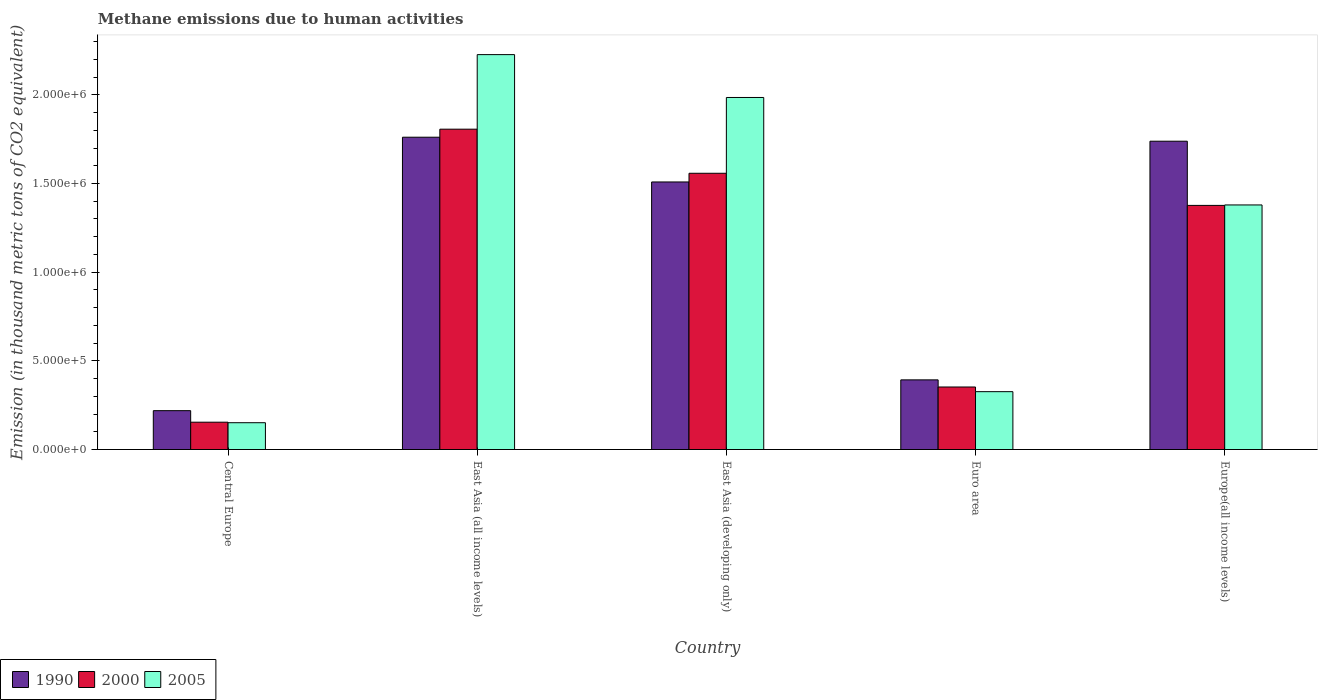How many different coloured bars are there?
Your answer should be very brief. 3. Are the number of bars per tick equal to the number of legend labels?
Ensure brevity in your answer.  Yes. What is the label of the 2nd group of bars from the left?
Your answer should be very brief. East Asia (all income levels). What is the amount of methane emitted in 2000 in East Asia (all income levels)?
Provide a succinct answer. 1.81e+06. Across all countries, what is the maximum amount of methane emitted in 2000?
Make the answer very short. 1.81e+06. Across all countries, what is the minimum amount of methane emitted in 2005?
Provide a short and direct response. 1.51e+05. In which country was the amount of methane emitted in 1990 maximum?
Offer a very short reply. East Asia (all income levels). In which country was the amount of methane emitted in 2005 minimum?
Give a very brief answer. Central Europe. What is the total amount of methane emitted in 1990 in the graph?
Ensure brevity in your answer.  5.62e+06. What is the difference between the amount of methane emitted in 1990 in East Asia (all income levels) and that in Euro area?
Your answer should be compact. 1.37e+06. What is the difference between the amount of methane emitted in 1990 in East Asia (all income levels) and the amount of methane emitted in 2000 in Europe(all income levels)?
Your answer should be very brief. 3.85e+05. What is the average amount of methane emitted in 2005 per country?
Give a very brief answer. 1.21e+06. What is the difference between the amount of methane emitted of/in 1990 and amount of methane emitted of/in 2000 in East Asia (developing only)?
Ensure brevity in your answer.  -4.90e+04. What is the ratio of the amount of methane emitted in 1990 in Central Europe to that in Europe(all income levels)?
Offer a very short reply. 0.13. Is the difference between the amount of methane emitted in 1990 in East Asia (all income levels) and Europe(all income levels) greater than the difference between the amount of methane emitted in 2000 in East Asia (all income levels) and Europe(all income levels)?
Your answer should be very brief. No. What is the difference between the highest and the second highest amount of methane emitted in 2000?
Your response must be concise. 2.49e+05. What is the difference between the highest and the lowest amount of methane emitted in 2005?
Offer a very short reply. 2.08e+06. In how many countries, is the amount of methane emitted in 2005 greater than the average amount of methane emitted in 2005 taken over all countries?
Provide a succinct answer. 3. Is the sum of the amount of methane emitted in 2005 in Central Europe and Europe(all income levels) greater than the maximum amount of methane emitted in 1990 across all countries?
Provide a succinct answer. No. What does the 1st bar from the right in Europe(all income levels) represents?
Your response must be concise. 2005. Where does the legend appear in the graph?
Give a very brief answer. Bottom left. How are the legend labels stacked?
Keep it short and to the point. Horizontal. What is the title of the graph?
Your response must be concise. Methane emissions due to human activities. Does "1963" appear as one of the legend labels in the graph?
Offer a terse response. No. What is the label or title of the X-axis?
Your answer should be very brief. Country. What is the label or title of the Y-axis?
Your answer should be compact. Emission (in thousand metric tons of CO2 equivalent). What is the Emission (in thousand metric tons of CO2 equivalent) of 1990 in Central Europe?
Make the answer very short. 2.19e+05. What is the Emission (in thousand metric tons of CO2 equivalent) in 2000 in Central Europe?
Ensure brevity in your answer.  1.54e+05. What is the Emission (in thousand metric tons of CO2 equivalent) in 2005 in Central Europe?
Keep it short and to the point. 1.51e+05. What is the Emission (in thousand metric tons of CO2 equivalent) of 1990 in East Asia (all income levels)?
Your answer should be very brief. 1.76e+06. What is the Emission (in thousand metric tons of CO2 equivalent) of 2000 in East Asia (all income levels)?
Make the answer very short. 1.81e+06. What is the Emission (in thousand metric tons of CO2 equivalent) in 2005 in East Asia (all income levels)?
Make the answer very short. 2.23e+06. What is the Emission (in thousand metric tons of CO2 equivalent) of 1990 in East Asia (developing only)?
Ensure brevity in your answer.  1.51e+06. What is the Emission (in thousand metric tons of CO2 equivalent) in 2000 in East Asia (developing only)?
Make the answer very short. 1.56e+06. What is the Emission (in thousand metric tons of CO2 equivalent) in 2005 in East Asia (developing only)?
Offer a terse response. 1.99e+06. What is the Emission (in thousand metric tons of CO2 equivalent) of 1990 in Euro area?
Offer a very short reply. 3.93e+05. What is the Emission (in thousand metric tons of CO2 equivalent) in 2000 in Euro area?
Offer a terse response. 3.53e+05. What is the Emission (in thousand metric tons of CO2 equivalent) of 2005 in Euro area?
Offer a very short reply. 3.26e+05. What is the Emission (in thousand metric tons of CO2 equivalent) of 1990 in Europe(all income levels)?
Your response must be concise. 1.74e+06. What is the Emission (in thousand metric tons of CO2 equivalent) in 2000 in Europe(all income levels)?
Keep it short and to the point. 1.38e+06. What is the Emission (in thousand metric tons of CO2 equivalent) of 2005 in Europe(all income levels)?
Make the answer very short. 1.38e+06. Across all countries, what is the maximum Emission (in thousand metric tons of CO2 equivalent) of 1990?
Give a very brief answer. 1.76e+06. Across all countries, what is the maximum Emission (in thousand metric tons of CO2 equivalent) of 2000?
Offer a very short reply. 1.81e+06. Across all countries, what is the maximum Emission (in thousand metric tons of CO2 equivalent) in 2005?
Keep it short and to the point. 2.23e+06. Across all countries, what is the minimum Emission (in thousand metric tons of CO2 equivalent) in 1990?
Your answer should be compact. 2.19e+05. Across all countries, what is the minimum Emission (in thousand metric tons of CO2 equivalent) in 2000?
Give a very brief answer. 1.54e+05. Across all countries, what is the minimum Emission (in thousand metric tons of CO2 equivalent) in 2005?
Give a very brief answer. 1.51e+05. What is the total Emission (in thousand metric tons of CO2 equivalent) of 1990 in the graph?
Give a very brief answer. 5.62e+06. What is the total Emission (in thousand metric tons of CO2 equivalent) in 2000 in the graph?
Make the answer very short. 5.25e+06. What is the total Emission (in thousand metric tons of CO2 equivalent) in 2005 in the graph?
Your answer should be compact. 6.07e+06. What is the difference between the Emission (in thousand metric tons of CO2 equivalent) in 1990 in Central Europe and that in East Asia (all income levels)?
Your answer should be compact. -1.54e+06. What is the difference between the Emission (in thousand metric tons of CO2 equivalent) of 2000 in Central Europe and that in East Asia (all income levels)?
Your answer should be compact. -1.65e+06. What is the difference between the Emission (in thousand metric tons of CO2 equivalent) in 2005 in Central Europe and that in East Asia (all income levels)?
Offer a terse response. -2.08e+06. What is the difference between the Emission (in thousand metric tons of CO2 equivalent) of 1990 in Central Europe and that in East Asia (developing only)?
Give a very brief answer. -1.29e+06. What is the difference between the Emission (in thousand metric tons of CO2 equivalent) in 2000 in Central Europe and that in East Asia (developing only)?
Ensure brevity in your answer.  -1.40e+06. What is the difference between the Emission (in thousand metric tons of CO2 equivalent) of 2005 in Central Europe and that in East Asia (developing only)?
Your response must be concise. -1.83e+06. What is the difference between the Emission (in thousand metric tons of CO2 equivalent) of 1990 in Central Europe and that in Euro area?
Keep it short and to the point. -1.74e+05. What is the difference between the Emission (in thousand metric tons of CO2 equivalent) of 2000 in Central Europe and that in Euro area?
Make the answer very short. -1.98e+05. What is the difference between the Emission (in thousand metric tons of CO2 equivalent) of 2005 in Central Europe and that in Euro area?
Make the answer very short. -1.75e+05. What is the difference between the Emission (in thousand metric tons of CO2 equivalent) of 1990 in Central Europe and that in Europe(all income levels)?
Provide a succinct answer. -1.52e+06. What is the difference between the Emission (in thousand metric tons of CO2 equivalent) of 2000 in Central Europe and that in Europe(all income levels)?
Offer a terse response. -1.22e+06. What is the difference between the Emission (in thousand metric tons of CO2 equivalent) of 2005 in Central Europe and that in Europe(all income levels)?
Your response must be concise. -1.23e+06. What is the difference between the Emission (in thousand metric tons of CO2 equivalent) of 1990 in East Asia (all income levels) and that in East Asia (developing only)?
Offer a terse response. 2.52e+05. What is the difference between the Emission (in thousand metric tons of CO2 equivalent) of 2000 in East Asia (all income levels) and that in East Asia (developing only)?
Offer a terse response. 2.49e+05. What is the difference between the Emission (in thousand metric tons of CO2 equivalent) in 2005 in East Asia (all income levels) and that in East Asia (developing only)?
Your response must be concise. 2.42e+05. What is the difference between the Emission (in thousand metric tons of CO2 equivalent) of 1990 in East Asia (all income levels) and that in Euro area?
Make the answer very short. 1.37e+06. What is the difference between the Emission (in thousand metric tons of CO2 equivalent) of 2000 in East Asia (all income levels) and that in Euro area?
Offer a very short reply. 1.45e+06. What is the difference between the Emission (in thousand metric tons of CO2 equivalent) in 2005 in East Asia (all income levels) and that in Euro area?
Offer a terse response. 1.90e+06. What is the difference between the Emission (in thousand metric tons of CO2 equivalent) in 1990 in East Asia (all income levels) and that in Europe(all income levels)?
Provide a short and direct response. 2.26e+04. What is the difference between the Emission (in thousand metric tons of CO2 equivalent) in 2000 in East Asia (all income levels) and that in Europe(all income levels)?
Offer a very short reply. 4.30e+05. What is the difference between the Emission (in thousand metric tons of CO2 equivalent) of 2005 in East Asia (all income levels) and that in Europe(all income levels)?
Provide a short and direct response. 8.48e+05. What is the difference between the Emission (in thousand metric tons of CO2 equivalent) of 1990 in East Asia (developing only) and that in Euro area?
Your answer should be compact. 1.12e+06. What is the difference between the Emission (in thousand metric tons of CO2 equivalent) in 2000 in East Asia (developing only) and that in Euro area?
Your answer should be very brief. 1.21e+06. What is the difference between the Emission (in thousand metric tons of CO2 equivalent) in 2005 in East Asia (developing only) and that in Euro area?
Your answer should be compact. 1.66e+06. What is the difference between the Emission (in thousand metric tons of CO2 equivalent) of 1990 in East Asia (developing only) and that in Europe(all income levels)?
Offer a terse response. -2.30e+05. What is the difference between the Emission (in thousand metric tons of CO2 equivalent) of 2000 in East Asia (developing only) and that in Europe(all income levels)?
Your response must be concise. 1.81e+05. What is the difference between the Emission (in thousand metric tons of CO2 equivalent) in 2005 in East Asia (developing only) and that in Europe(all income levels)?
Your response must be concise. 6.06e+05. What is the difference between the Emission (in thousand metric tons of CO2 equivalent) of 1990 in Euro area and that in Europe(all income levels)?
Your response must be concise. -1.35e+06. What is the difference between the Emission (in thousand metric tons of CO2 equivalent) in 2000 in Euro area and that in Europe(all income levels)?
Provide a short and direct response. -1.02e+06. What is the difference between the Emission (in thousand metric tons of CO2 equivalent) of 2005 in Euro area and that in Europe(all income levels)?
Make the answer very short. -1.05e+06. What is the difference between the Emission (in thousand metric tons of CO2 equivalent) of 1990 in Central Europe and the Emission (in thousand metric tons of CO2 equivalent) of 2000 in East Asia (all income levels)?
Keep it short and to the point. -1.59e+06. What is the difference between the Emission (in thousand metric tons of CO2 equivalent) in 1990 in Central Europe and the Emission (in thousand metric tons of CO2 equivalent) in 2005 in East Asia (all income levels)?
Provide a short and direct response. -2.01e+06. What is the difference between the Emission (in thousand metric tons of CO2 equivalent) in 2000 in Central Europe and the Emission (in thousand metric tons of CO2 equivalent) in 2005 in East Asia (all income levels)?
Keep it short and to the point. -2.07e+06. What is the difference between the Emission (in thousand metric tons of CO2 equivalent) of 1990 in Central Europe and the Emission (in thousand metric tons of CO2 equivalent) of 2000 in East Asia (developing only)?
Your answer should be very brief. -1.34e+06. What is the difference between the Emission (in thousand metric tons of CO2 equivalent) of 1990 in Central Europe and the Emission (in thousand metric tons of CO2 equivalent) of 2005 in East Asia (developing only)?
Keep it short and to the point. -1.77e+06. What is the difference between the Emission (in thousand metric tons of CO2 equivalent) in 2000 in Central Europe and the Emission (in thousand metric tons of CO2 equivalent) in 2005 in East Asia (developing only)?
Provide a short and direct response. -1.83e+06. What is the difference between the Emission (in thousand metric tons of CO2 equivalent) of 1990 in Central Europe and the Emission (in thousand metric tons of CO2 equivalent) of 2000 in Euro area?
Provide a succinct answer. -1.33e+05. What is the difference between the Emission (in thousand metric tons of CO2 equivalent) in 1990 in Central Europe and the Emission (in thousand metric tons of CO2 equivalent) in 2005 in Euro area?
Your response must be concise. -1.07e+05. What is the difference between the Emission (in thousand metric tons of CO2 equivalent) in 2000 in Central Europe and the Emission (in thousand metric tons of CO2 equivalent) in 2005 in Euro area?
Keep it short and to the point. -1.72e+05. What is the difference between the Emission (in thousand metric tons of CO2 equivalent) in 1990 in Central Europe and the Emission (in thousand metric tons of CO2 equivalent) in 2000 in Europe(all income levels)?
Make the answer very short. -1.16e+06. What is the difference between the Emission (in thousand metric tons of CO2 equivalent) in 1990 in Central Europe and the Emission (in thousand metric tons of CO2 equivalent) in 2005 in Europe(all income levels)?
Offer a very short reply. -1.16e+06. What is the difference between the Emission (in thousand metric tons of CO2 equivalent) in 2000 in Central Europe and the Emission (in thousand metric tons of CO2 equivalent) in 2005 in Europe(all income levels)?
Make the answer very short. -1.23e+06. What is the difference between the Emission (in thousand metric tons of CO2 equivalent) in 1990 in East Asia (all income levels) and the Emission (in thousand metric tons of CO2 equivalent) in 2000 in East Asia (developing only)?
Offer a very short reply. 2.03e+05. What is the difference between the Emission (in thousand metric tons of CO2 equivalent) in 1990 in East Asia (all income levels) and the Emission (in thousand metric tons of CO2 equivalent) in 2005 in East Asia (developing only)?
Your response must be concise. -2.24e+05. What is the difference between the Emission (in thousand metric tons of CO2 equivalent) of 2000 in East Asia (all income levels) and the Emission (in thousand metric tons of CO2 equivalent) of 2005 in East Asia (developing only)?
Offer a terse response. -1.79e+05. What is the difference between the Emission (in thousand metric tons of CO2 equivalent) of 1990 in East Asia (all income levels) and the Emission (in thousand metric tons of CO2 equivalent) of 2000 in Euro area?
Your response must be concise. 1.41e+06. What is the difference between the Emission (in thousand metric tons of CO2 equivalent) in 1990 in East Asia (all income levels) and the Emission (in thousand metric tons of CO2 equivalent) in 2005 in Euro area?
Keep it short and to the point. 1.43e+06. What is the difference between the Emission (in thousand metric tons of CO2 equivalent) in 2000 in East Asia (all income levels) and the Emission (in thousand metric tons of CO2 equivalent) in 2005 in Euro area?
Keep it short and to the point. 1.48e+06. What is the difference between the Emission (in thousand metric tons of CO2 equivalent) in 1990 in East Asia (all income levels) and the Emission (in thousand metric tons of CO2 equivalent) in 2000 in Europe(all income levels)?
Your response must be concise. 3.85e+05. What is the difference between the Emission (in thousand metric tons of CO2 equivalent) of 1990 in East Asia (all income levels) and the Emission (in thousand metric tons of CO2 equivalent) of 2005 in Europe(all income levels)?
Keep it short and to the point. 3.82e+05. What is the difference between the Emission (in thousand metric tons of CO2 equivalent) in 2000 in East Asia (all income levels) and the Emission (in thousand metric tons of CO2 equivalent) in 2005 in Europe(all income levels)?
Make the answer very short. 4.27e+05. What is the difference between the Emission (in thousand metric tons of CO2 equivalent) of 1990 in East Asia (developing only) and the Emission (in thousand metric tons of CO2 equivalent) of 2000 in Euro area?
Offer a very short reply. 1.16e+06. What is the difference between the Emission (in thousand metric tons of CO2 equivalent) in 1990 in East Asia (developing only) and the Emission (in thousand metric tons of CO2 equivalent) in 2005 in Euro area?
Your answer should be very brief. 1.18e+06. What is the difference between the Emission (in thousand metric tons of CO2 equivalent) of 2000 in East Asia (developing only) and the Emission (in thousand metric tons of CO2 equivalent) of 2005 in Euro area?
Provide a succinct answer. 1.23e+06. What is the difference between the Emission (in thousand metric tons of CO2 equivalent) in 1990 in East Asia (developing only) and the Emission (in thousand metric tons of CO2 equivalent) in 2000 in Europe(all income levels)?
Your answer should be compact. 1.32e+05. What is the difference between the Emission (in thousand metric tons of CO2 equivalent) in 1990 in East Asia (developing only) and the Emission (in thousand metric tons of CO2 equivalent) in 2005 in Europe(all income levels)?
Offer a terse response. 1.30e+05. What is the difference between the Emission (in thousand metric tons of CO2 equivalent) of 2000 in East Asia (developing only) and the Emission (in thousand metric tons of CO2 equivalent) of 2005 in Europe(all income levels)?
Provide a succinct answer. 1.79e+05. What is the difference between the Emission (in thousand metric tons of CO2 equivalent) of 1990 in Euro area and the Emission (in thousand metric tons of CO2 equivalent) of 2000 in Europe(all income levels)?
Ensure brevity in your answer.  -9.84e+05. What is the difference between the Emission (in thousand metric tons of CO2 equivalent) in 1990 in Euro area and the Emission (in thousand metric tons of CO2 equivalent) in 2005 in Europe(all income levels)?
Make the answer very short. -9.86e+05. What is the difference between the Emission (in thousand metric tons of CO2 equivalent) in 2000 in Euro area and the Emission (in thousand metric tons of CO2 equivalent) in 2005 in Europe(all income levels)?
Make the answer very short. -1.03e+06. What is the average Emission (in thousand metric tons of CO2 equivalent) in 1990 per country?
Provide a succinct answer. 1.12e+06. What is the average Emission (in thousand metric tons of CO2 equivalent) of 2000 per country?
Keep it short and to the point. 1.05e+06. What is the average Emission (in thousand metric tons of CO2 equivalent) in 2005 per country?
Your answer should be very brief. 1.21e+06. What is the difference between the Emission (in thousand metric tons of CO2 equivalent) of 1990 and Emission (in thousand metric tons of CO2 equivalent) of 2000 in Central Europe?
Provide a short and direct response. 6.50e+04. What is the difference between the Emission (in thousand metric tons of CO2 equivalent) of 1990 and Emission (in thousand metric tons of CO2 equivalent) of 2005 in Central Europe?
Your answer should be very brief. 6.80e+04. What is the difference between the Emission (in thousand metric tons of CO2 equivalent) in 2000 and Emission (in thousand metric tons of CO2 equivalent) in 2005 in Central Europe?
Your answer should be compact. 2935.3. What is the difference between the Emission (in thousand metric tons of CO2 equivalent) of 1990 and Emission (in thousand metric tons of CO2 equivalent) of 2000 in East Asia (all income levels)?
Offer a terse response. -4.52e+04. What is the difference between the Emission (in thousand metric tons of CO2 equivalent) in 1990 and Emission (in thousand metric tons of CO2 equivalent) in 2005 in East Asia (all income levels)?
Offer a terse response. -4.66e+05. What is the difference between the Emission (in thousand metric tons of CO2 equivalent) in 2000 and Emission (in thousand metric tons of CO2 equivalent) in 2005 in East Asia (all income levels)?
Give a very brief answer. -4.20e+05. What is the difference between the Emission (in thousand metric tons of CO2 equivalent) in 1990 and Emission (in thousand metric tons of CO2 equivalent) in 2000 in East Asia (developing only)?
Offer a very short reply. -4.90e+04. What is the difference between the Emission (in thousand metric tons of CO2 equivalent) in 1990 and Emission (in thousand metric tons of CO2 equivalent) in 2005 in East Asia (developing only)?
Your answer should be compact. -4.76e+05. What is the difference between the Emission (in thousand metric tons of CO2 equivalent) in 2000 and Emission (in thousand metric tons of CO2 equivalent) in 2005 in East Asia (developing only)?
Your answer should be compact. -4.27e+05. What is the difference between the Emission (in thousand metric tons of CO2 equivalent) of 1990 and Emission (in thousand metric tons of CO2 equivalent) of 2000 in Euro area?
Offer a very short reply. 4.02e+04. What is the difference between the Emission (in thousand metric tons of CO2 equivalent) of 1990 and Emission (in thousand metric tons of CO2 equivalent) of 2005 in Euro area?
Keep it short and to the point. 6.66e+04. What is the difference between the Emission (in thousand metric tons of CO2 equivalent) of 2000 and Emission (in thousand metric tons of CO2 equivalent) of 2005 in Euro area?
Keep it short and to the point. 2.63e+04. What is the difference between the Emission (in thousand metric tons of CO2 equivalent) of 1990 and Emission (in thousand metric tons of CO2 equivalent) of 2000 in Europe(all income levels)?
Your answer should be compact. 3.62e+05. What is the difference between the Emission (in thousand metric tons of CO2 equivalent) in 1990 and Emission (in thousand metric tons of CO2 equivalent) in 2005 in Europe(all income levels)?
Provide a succinct answer. 3.59e+05. What is the difference between the Emission (in thousand metric tons of CO2 equivalent) in 2000 and Emission (in thousand metric tons of CO2 equivalent) in 2005 in Europe(all income levels)?
Offer a terse response. -2537.9. What is the ratio of the Emission (in thousand metric tons of CO2 equivalent) in 1990 in Central Europe to that in East Asia (all income levels)?
Ensure brevity in your answer.  0.12. What is the ratio of the Emission (in thousand metric tons of CO2 equivalent) in 2000 in Central Europe to that in East Asia (all income levels)?
Provide a succinct answer. 0.09. What is the ratio of the Emission (in thousand metric tons of CO2 equivalent) of 2005 in Central Europe to that in East Asia (all income levels)?
Offer a very short reply. 0.07. What is the ratio of the Emission (in thousand metric tons of CO2 equivalent) of 1990 in Central Europe to that in East Asia (developing only)?
Provide a short and direct response. 0.15. What is the ratio of the Emission (in thousand metric tons of CO2 equivalent) in 2000 in Central Europe to that in East Asia (developing only)?
Provide a succinct answer. 0.1. What is the ratio of the Emission (in thousand metric tons of CO2 equivalent) in 2005 in Central Europe to that in East Asia (developing only)?
Ensure brevity in your answer.  0.08. What is the ratio of the Emission (in thousand metric tons of CO2 equivalent) of 1990 in Central Europe to that in Euro area?
Offer a terse response. 0.56. What is the ratio of the Emission (in thousand metric tons of CO2 equivalent) in 2000 in Central Europe to that in Euro area?
Provide a short and direct response. 0.44. What is the ratio of the Emission (in thousand metric tons of CO2 equivalent) in 2005 in Central Europe to that in Euro area?
Provide a succinct answer. 0.46. What is the ratio of the Emission (in thousand metric tons of CO2 equivalent) in 1990 in Central Europe to that in Europe(all income levels)?
Keep it short and to the point. 0.13. What is the ratio of the Emission (in thousand metric tons of CO2 equivalent) in 2000 in Central Europe to that in Europe(all income levels)?
Give a very brief answer. 0.11. What is the ratio of the Emission (in thousand metric tons of CO2 equivalent) of 2005 in Central Europe to that in Europe(all income levels)?
Provide a succinct answer. 0.11. What is the ratio of the Emission (in thousand metric tons of CO2 equivalent) of 1990 in East Asia (all income levels) to that in East Asia (developing only)?
Your response must be concise. 1.17. What is the ratio of the Emission (in thousand metric tons of CO2 equivalent) of 2000 in East Asia (all income levels) to that in East Asia (developing only)?
Offer a very short reply. 1.16. What is the ratio of the Emission (in thousand metric tons of CO2 equivalent) of 2005 in East Asia (all income levels) to that in East Asia (developing only)?
Provide a short and direct response. 1.12. What is the ratio of the Emission (in thousand metric tons of CO2 equivalent) in 1990 in East Asia (all income levels) to that in Euro area?
Provide a succinct answer. 4.48. What is the ratio of the Emission (in thousand metric tons of CO2 equivalent) in 2000 in East Asia (all income levels) to that in Euro area?
Ensure brevity in your answer.  5.12. What is the ratio of the Emission (in thousand metric tons of CO2 equivalent) in 2005 in East Asia (all income levels) to that in Euro area?
Provide a short and direct response. 6.83. What is the ratio of the Emission (in thousand metric tons of CO2 equivalent) of 1990 in East Asia (all income levels) to that in Europe(all income levels)?
Offer a very short reply. 1.01. What is the ratio of the Emission (in thousand metric tons of CO2 equivalent) in 2000 in East Asia (all income levels) to that in Europe(all income levels)?
Offer a very short reply. 1.31. What is the ratio of the Emission (in thousand metric tons of CO2 equivalent) of 2005 in East Asia (all income levels) to that in Europe(all income levels)?
Your answer should be compact. 1.61. What is the ratio of the Emission (in thousand metric tons of CO2 equivalent) in 1990 in East Asia (developing only) to that in Euro area?
Offer a terse response. 3.84. What is the ratio of the Emission (in thousand metric tons of CO2 equivalent) of 2000 in East Asia (developing only) to that in Euro area?
Your answer should be compact. 4.42. What is the ratio of the Emission (in thousand metric tons of CO2 equivalent) in 2005 in East Asia (developing only) to that in Euro area?
Your response must be concise. 6.09. What is the ratio of the Emission (in thousand metric tons of CO2 equivalent) of 1990 in East Asia (developing only) to that in Europe(all income levels)?
Provide a succinct answer. 0.87. What is the ratio of the Emission (in thousand metric tons of CO2 equivalent) in 2000 in East Asia (developing only) to that in Europe(all income levels)?
Offer a very short reply. 1.13. What is the ratio of the Emission (in thousand metric tons of CO2 equivalent) in 2005 in East Asia (developing only) to that in Europe(all income levels)?
Keep it short and to the point. 1.44. What is the ratio of the Emission (in thousand metric tons of CO2 equivalent) in 1990 in Euro area to that in Europe(all income levels)?
Offer a very short reply. 0.23. What is the ratio of the Emission (in thousand metric tons of CO2 equivalent) in 2000 in Euro area to that in Europe(all income levels)?
Make the answer very short. 0.26. What is the ratio of the Emission (in thousand metric tons of CO2 equivalent) of 2005 in Euro area to that in Europe(all income levels)?
Offer a terse response. 0.24. What is the difference between the highest and the second highest Emission (in thousand metric tons of CO2 equivalent) of 1990?
Provide a succinct answer. 2.26e+04. What is the difference between the highest and the second highest Emission (in thousand metric tons of CO2 equivalent) in 2000?
Keep it short and to the point. 2.49e+05. What is the difference between the highest and the second highest Emission (in thousand metric tons of CO2 equivalent) in 2005?
Ensure brevity in your answer.  2.42e+05. What is the difference between the highest and the lowest Emission (in thousand metric tons of CO2 equivalent) of 1990?
Give a very brief answer. 1.54e+06. What is the difference between the highest and the lowest Emission (in thousand metric tons of CO2 equivalent) of 2000?
Your answer should be very brief. 1.65e+06. What is the difference between the highest and the lowest Emission (in thousand metric tons of CO2 equivalent) of 2005?
Provide a short and direct response. 2.08e+06. 